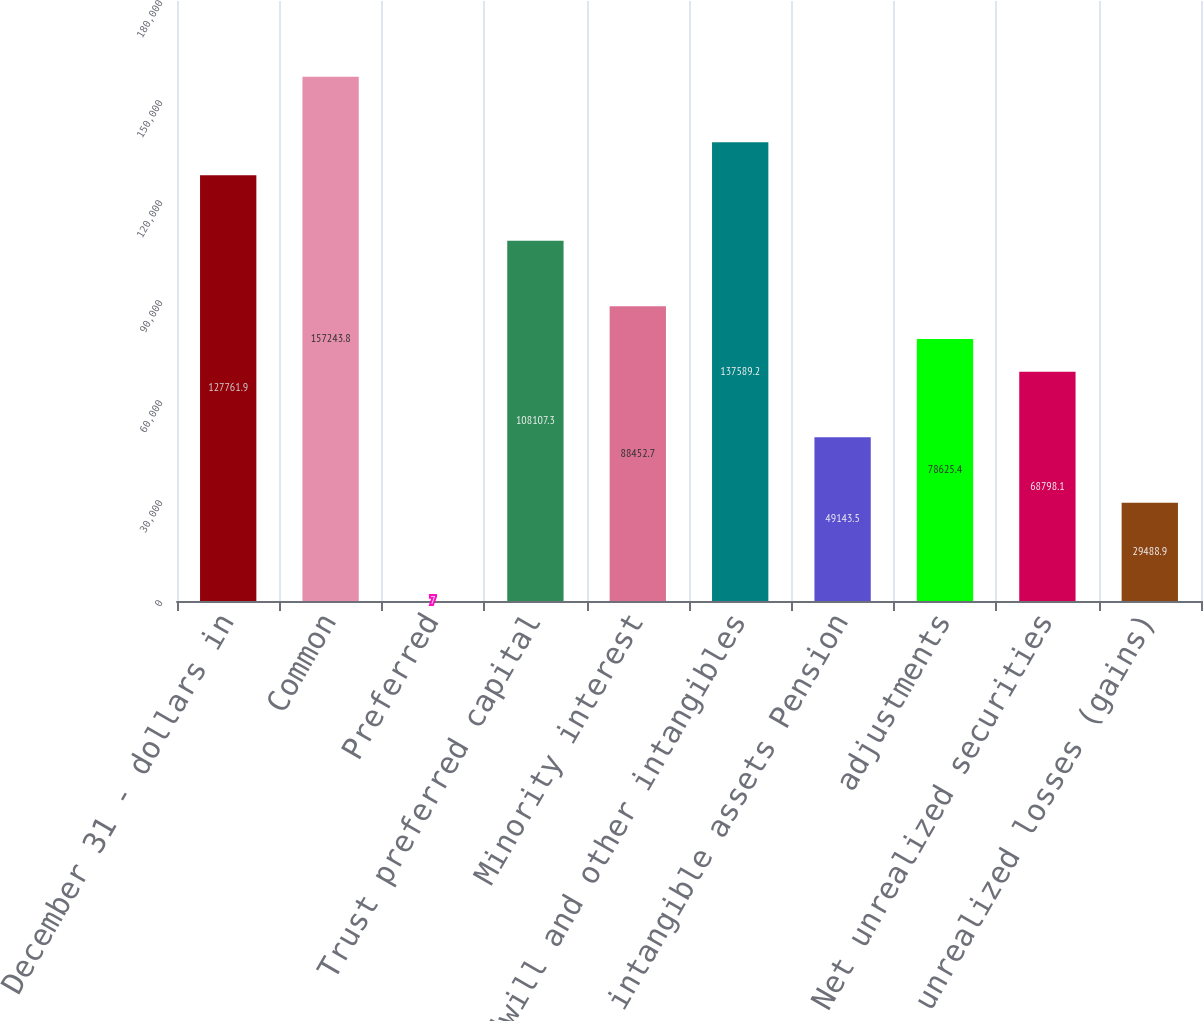<chart> <loc_0><loc_0><loc_500><loc_500><bar_chart><fcel>December 31 - dollars in<fcel>Common<fcel>Preferred<fcel>Trust preferred capital<fcel>Minority interest<fcel>Goodwill and other intangibles<fcel>intangible assets Pension<fcel>adjustments<fcel>Net unrealized securities<fcel>Net unrealized losses (gains)<nl><fcel>127762<fcel>157244<fcel>7<fcel>108107<fcel>88452.7<fcel>137589<fcel>49143.5<fcel>78625.4<fcel>68798.1<fcel>29488.9<nl></chart> 